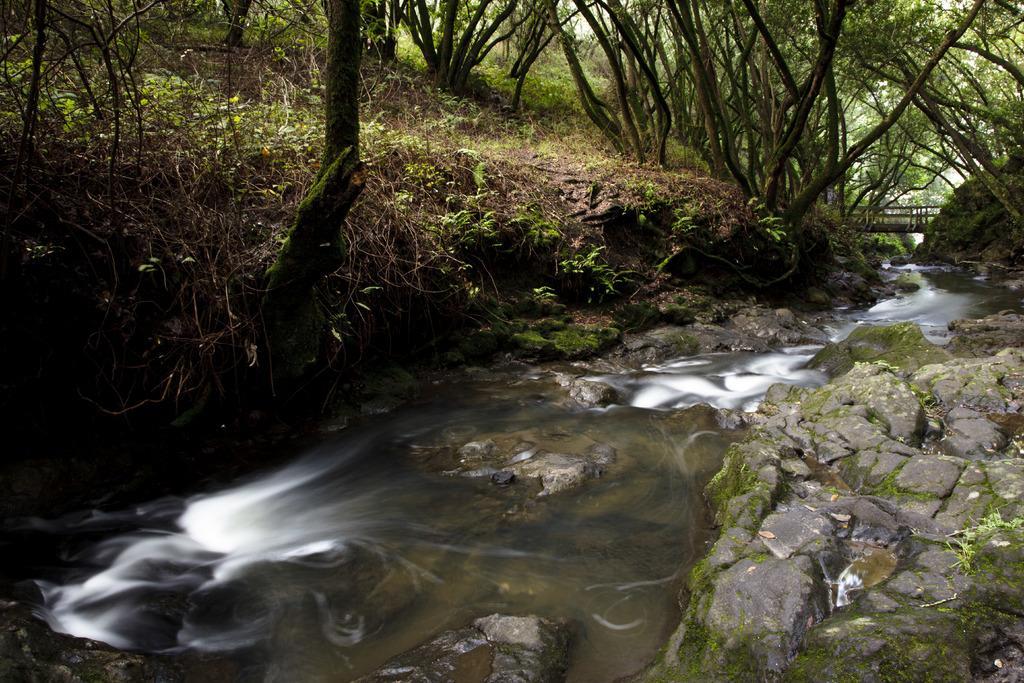Describe this image in one or two sentences. In this image I can see few trees, grass, water, few stones and the bridge. 